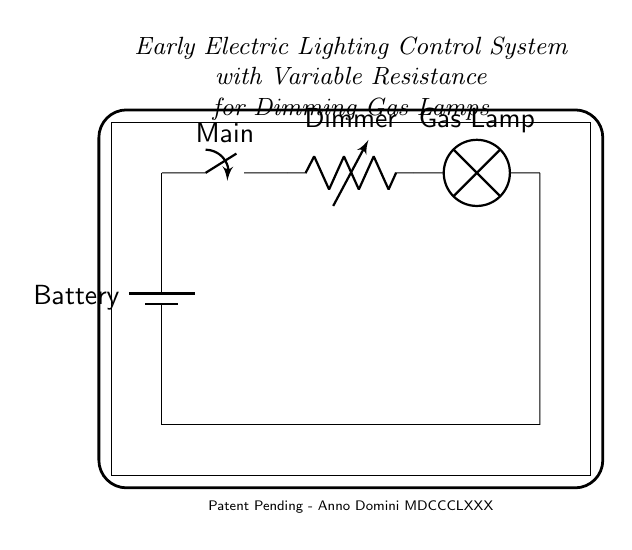What type of switch is used in this circuit? The circuit uses a main switch, indicated by the label in the diagram.
Answer: main switch What component is responsible for dimming the light? The dimming of the light is achieved by the variable resistor, commonly referred to as a dimmer in this circuit.
Answer: variable resistor What is the function of the battery in this circuit? The battery provides the necessary voltage and current to power the entire circuit, supplying energy for the gas lamp to illuminate.
Answer: power supply How many components are connected in series in this circuit? All four components: the battery, switch, variable resistor, and gas lamp are connected in series, as they form a single path for current flow.
Answer: four What happens to the brightness of the gas lamp when the variable resistor is adjusted? Adjusting the variable resistor alters the resistance in the circuit, which changes the current flow through the lamp, thus affecting its brightness level.
Answer: brightness varies Why is a variable resistor used instead of a fixed resistor? A variable resistor allows for adjustments in resistance, enabling the user to control the brightness of the gas lamp, whereas a fixed resistor would not provide this functionality.
Answer: control brightness What is the historical significance of this circuit design? This circuit represents an early attempt to electrically control gas lamps, showcasing advancements in electrical engineering during the Victorian era.
Answer: early control technology 